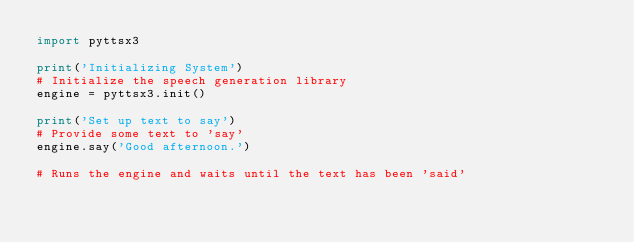Convert code to text. <code><loc_0><loc_0><loc_500><loc_500><_Python_>import pyttsx3

print('Initializing System')
# Initialize the speech generation library
engine = pyttsx3.init()

print('Set up text to say')
# Provide some text to 'say'
engine.say('Good afternoon.')

# Runs the engine and waits until the text has been 'said'</code> 